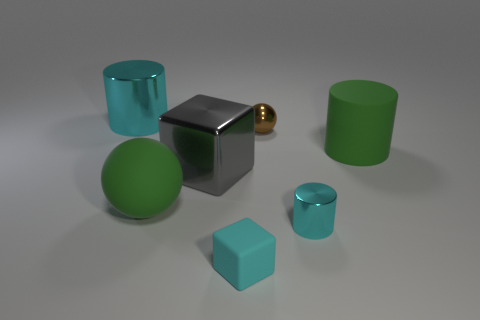Add 1 matte objects. How many objects exist? 8 Subtract all cylinders. How many objects are left? 4 Add 6 blue metallic things. How many blue metallic things exist? 6 Subtract 0 red spheres. How many objects are left? 7 Subtract all small cyan things. Subtract all spheres. How many objects are left? 3 Add 4 cyan matte things. How many cyan matte things are left? 5 